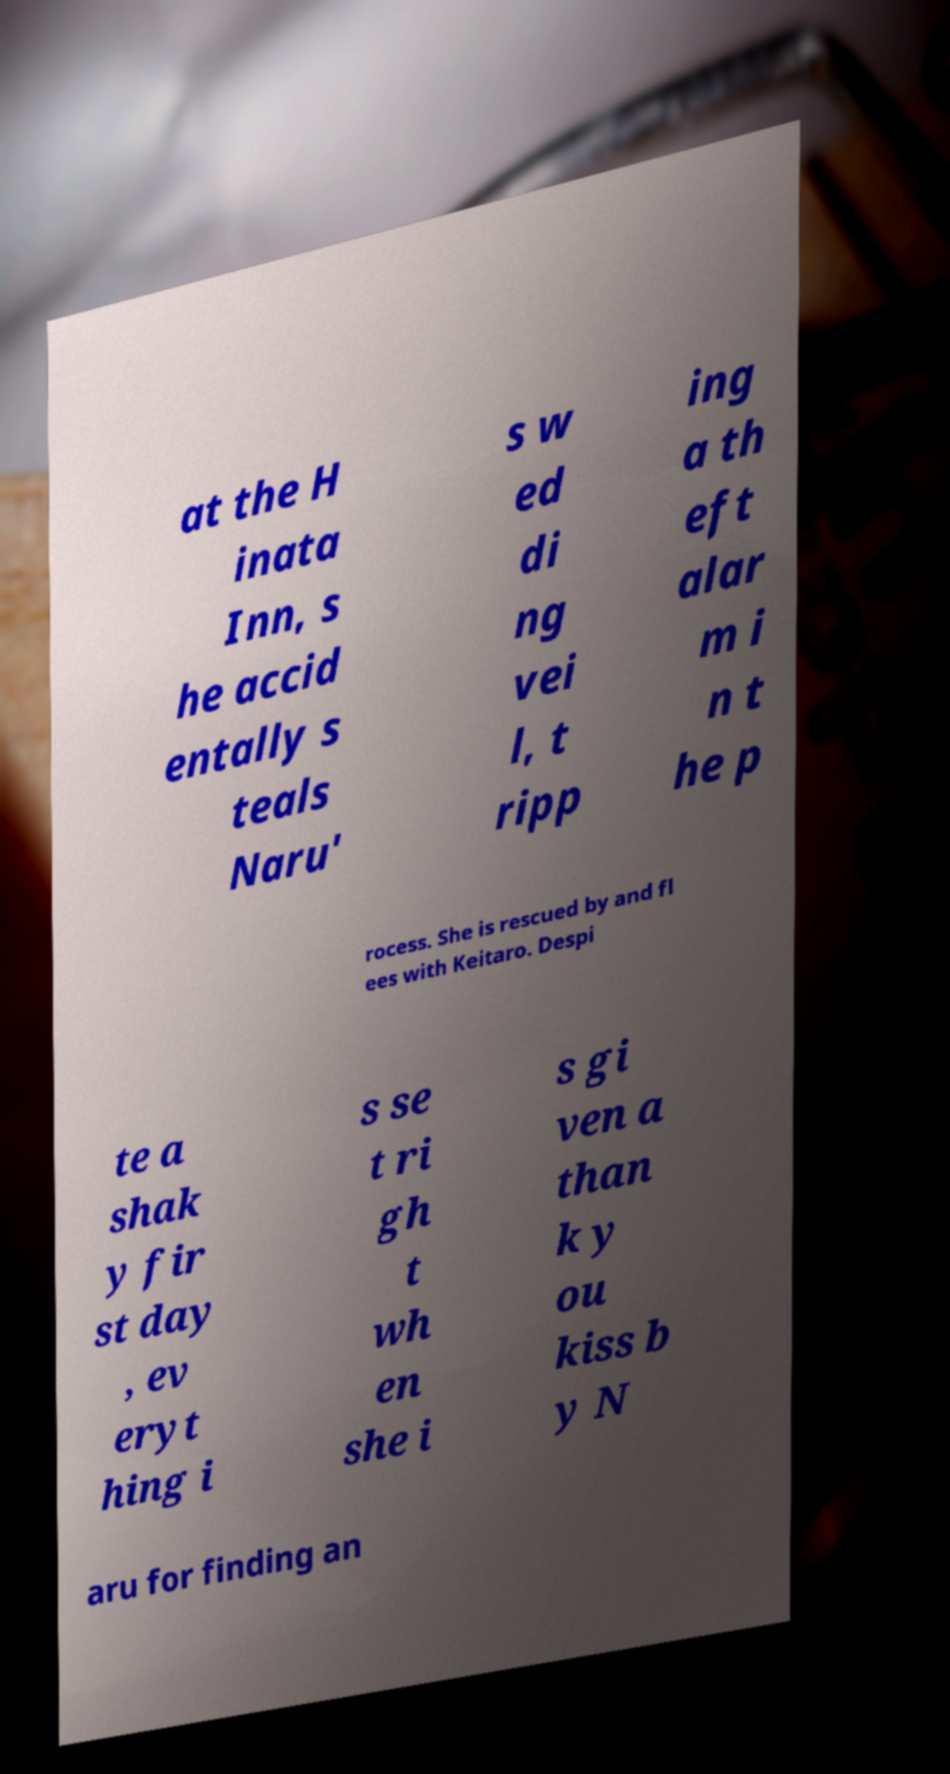I need the written content from this picture converted into text. Can you do that? at the H inata Inn, s he accid entally s teals Naru' s w ed di ng vei l, t ripp ing a th eft alar m i n t he p rocess. She is rescued by and fl ees with Keitaro. Despi te a shak y fir st day , ev eryt hing i s se t ri gh t wh en she i s gi ven a than k y ou kiss b y N aru for finding an 